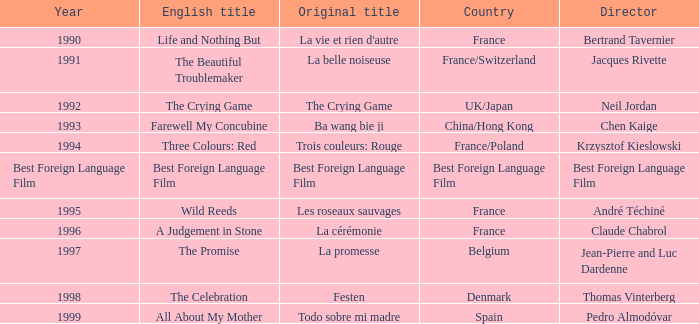What is the first title of the english title a judgement in stone? La cérémonie. 